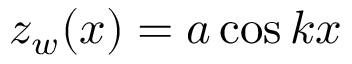Convert formula to latex. <formula><loc_0><loc_0><loc_500><loc_500>z _ { w } ( x ) = a \cos { k x }</formula> 